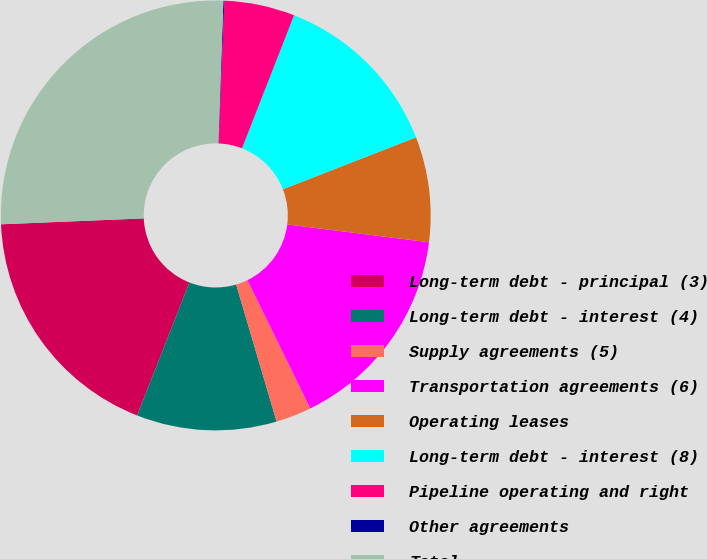Convert chart. <chart><loc_0><loc_0><loc_500><loc_500><pie_chart><fcel>Long-term debt - principal (3)<fcel>Long-term debt - interest (4)<fcel>Supply agreements (5)<fcel>Transportation agreements (6)<fcel>Operating leases<fcel>Long-term debt - interest (8)<fcel>Pipeline operating and right<fcel>Other agreements<fcel>Total<nl><fcel>18.38%<fcel>10.53%<fcel>2.68%<fcel>15.76%<fcel>7.91%<fcel>13.15%<fcel>5.3%<fcel>0.07%<fcel>26.22%<nl></chart> 